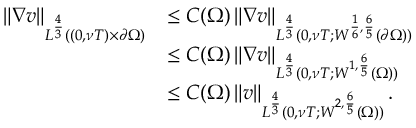<formula> <loc_0><loc_0><loc_500><loc_500>\begin{array} { r l } { \left \| \nabla v \right \| _ { L ^ { \frac { 4 } { 3 } } ( ( 0 , \nu T ) \times \partial \Omega ) } } & { \leq C ( \Omega ) \left \| \nabla v \right \| _ { L ^ { \frac { 4 } { 3 } } ( 0 , \nu T ; W ^ { \frac { 1 } { 6 } , \frac { 6 } { 5 } } ( \partial \Omega ) ) } } \\ & { \leq C ( \Omega ) \left \| \nabla v \right \| _ { L ^ { \frac { 4 } { 3 } } ( 0 , \nu T ; W ^ { 1 , \frac { 6 } { 5 } } ( \Omega ) ) } } \\ & { \leq C ( \Omega ) \left \| v \right \| _ { L ^ { \frac { 4 } { 3 } } ( 0 , \nu T ; W ^ { 2 , \frac { 6 } { 5 } } ( \Omega ) ) } . } \end{array}</formula> 